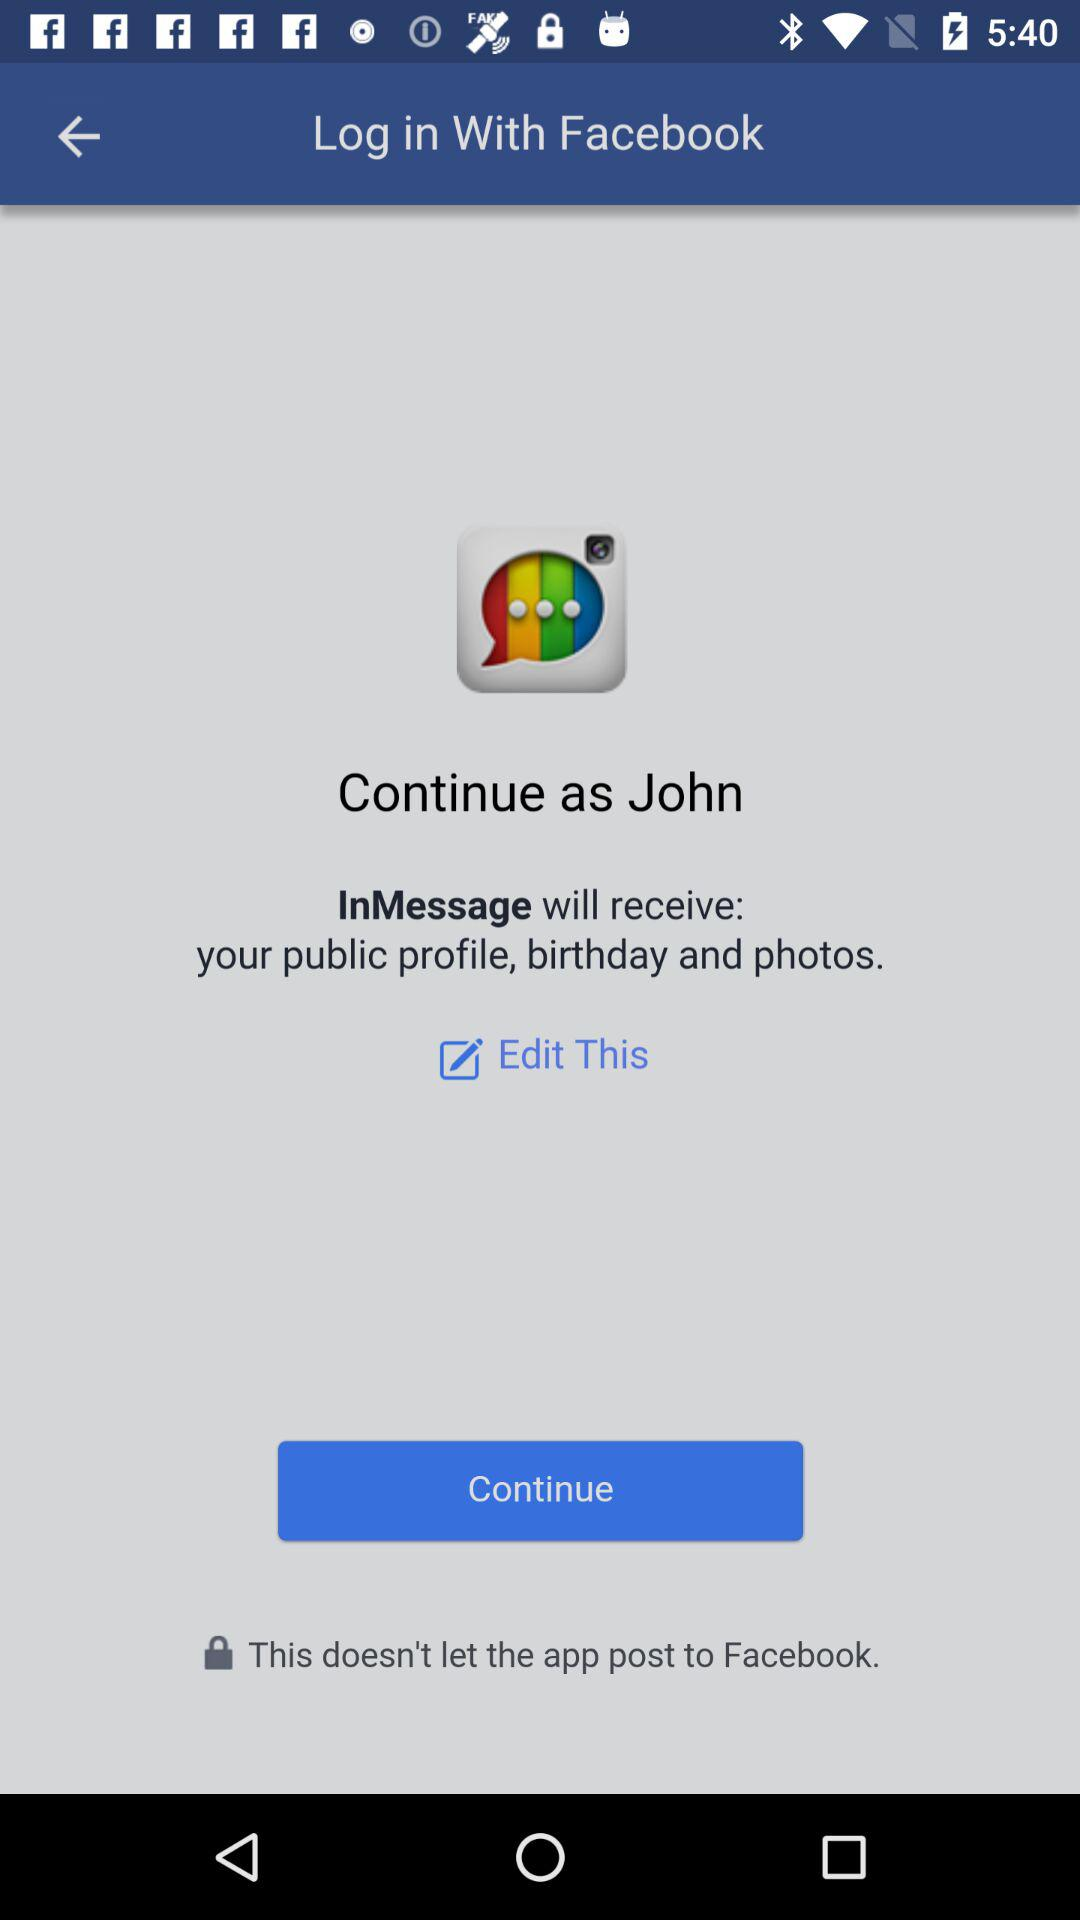With what application can we log in? You can log in with "Facebook". 